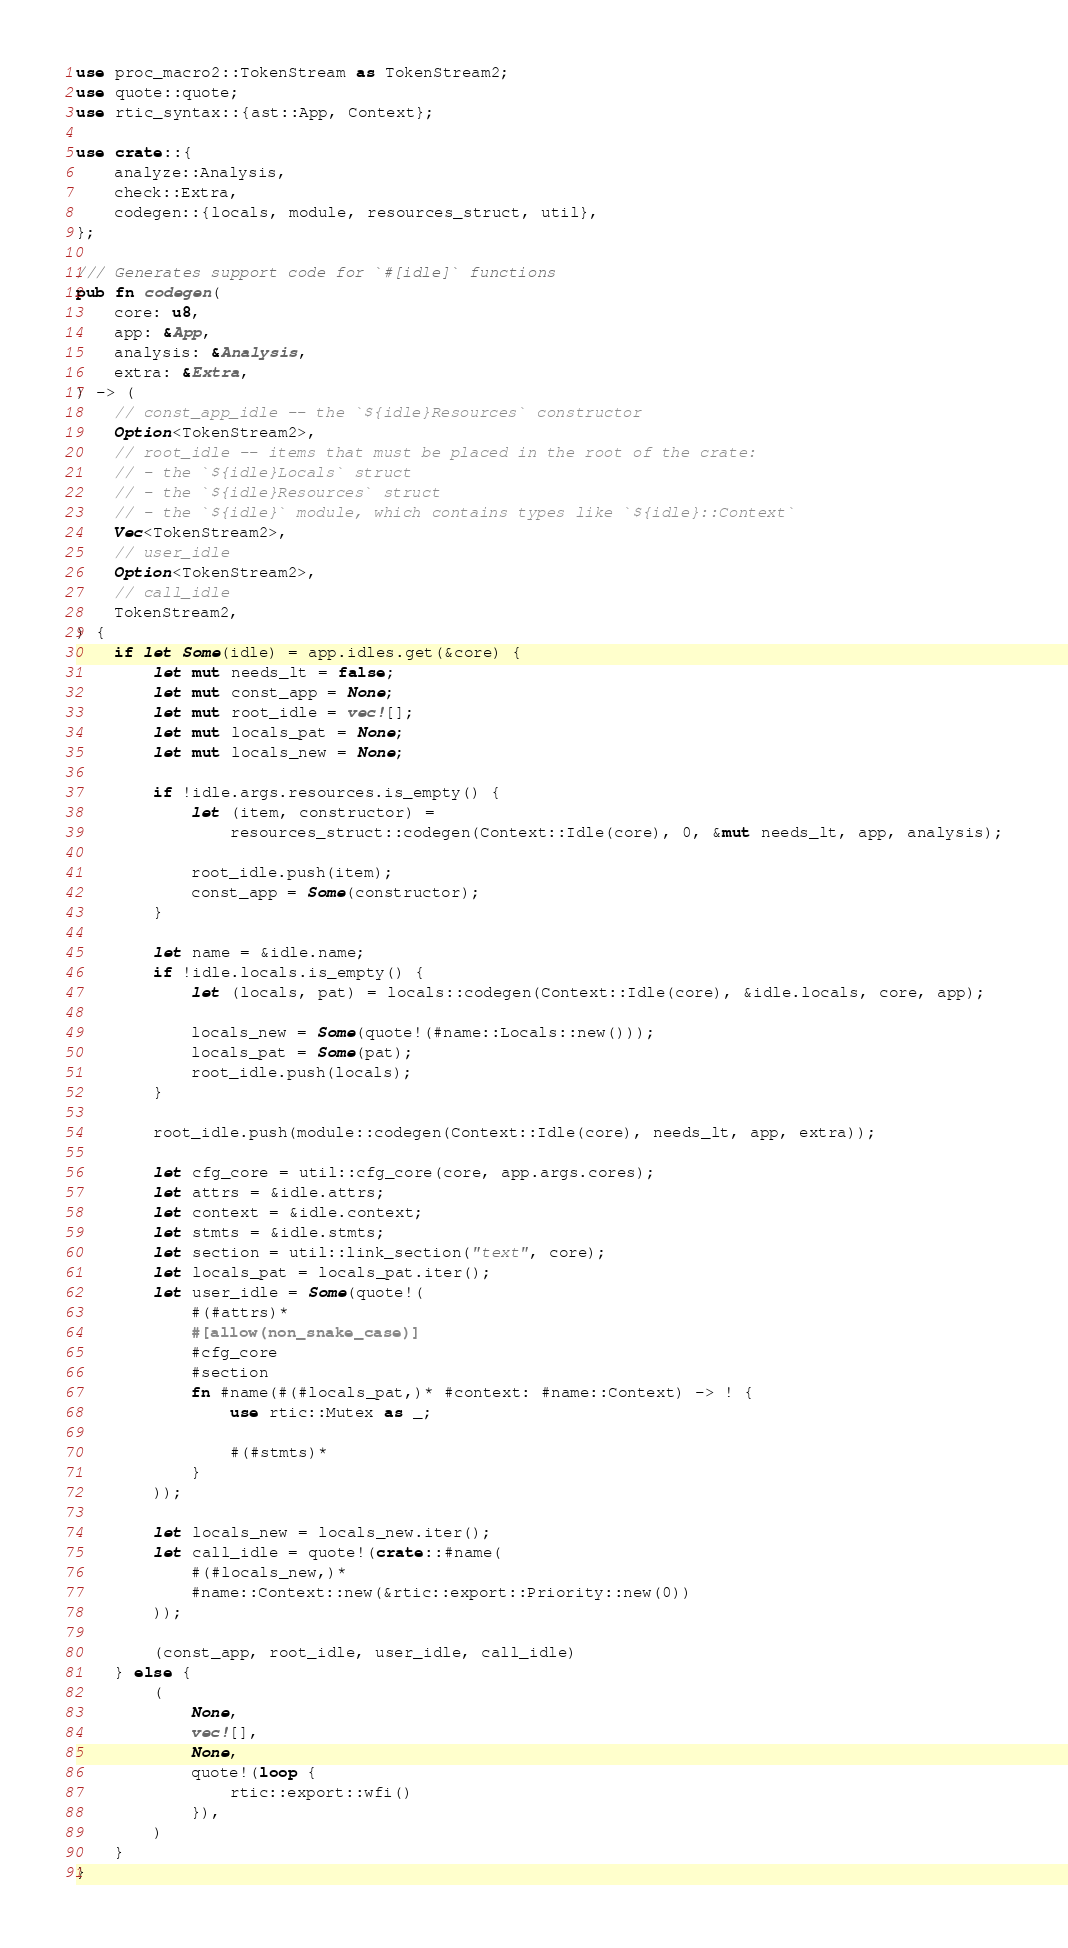Convert code to text. <code><loc_0><loc_0><loc_500><loc_500><_Rust_>use proc_macro2::TokenStream as TokenStream2;
use quote::quote;
use rtic_syntax::{ast::App, Context};

use crate::{
    analyze::Analysis,
    check::Extra,
    codegen::{locals, module, resources_struct, util},
};

/// Generates support code for `#[idle]` functions
pub fn codegen(
    core: u8,
    app: &App,
    analysis: &Analysis,
    extra: &Extra,
) -> (
    // const_app_idle -- the `${idle}Resources` constructor
    Option<TokenStream2>,
    // root_idle -- items that must be placed in the root of the crate:
    // - the `${idle}Locals` struct
    // - the `${idle}Resources` struct
    // - the `${idle}` module, which contains types like `${idle}::Context`
    Vec<TokenStream2>,
    // user_idle
    Option<TokenStream2>,
    // call_idle
    TokenStream2,
) {
    if let Some(idle) = app.idles.get(&core) {
        let mut needs_lt = false;
        let mut const_app = None;
        let mut root_idle = vec![];
        let mut locals_pat = None;
        let mut locals_new = None;

        if !idle.args.resources.is_empty() {
            let (item, constructor) =
                resources_struct::codegen(Context::Idle(core), 0, &mut needs_lt, app, analysis);

            root_idle.push(item);
            const_app = Some(constructor);
        }

        let name = &idle.name;
        if !idle.locals.is_empty() {
            let (locals, pat) = locals::codegen(Context::Idle(core), &idle.locals, core, app);

            locals_new = Some(quote!(#name::Locals::new()));
            locals_pat = Some(pat);
            root_idle.push(locals);
        }

        root_idle.push(module::codegen(Context::Idle(core), needs_lt, app, extra));

        let cfg_core = util::cfg_core(core, app.args.cores);
        let attrs = &idle.attrs;
        let context = &idle.context;
        let stmts = &idle.stmts;
        let section = util::link_section("text", core);
        let locals_pat = locals_pat.iter();
        let user_idle = Some(quote!(
            #(#attrs)*
            #[allow(non_snake_case)]
            #cfg_core
            #section
            fn #name(#(#locals_pat,)* #context: #name::Context) -> ! {
                use rtic::Mutex as _;

                #(#stmts)*
            }
        ));

        let locals_new = locals_new.iter();
        let call_idle = quote!(crate::#name(
            #(#locals_new,)*
            #name::Context::new(&rtic::export::Priority::new(0))
        ));

        (const_app, root_idle, user_idle, call_idle)
    } else {
        (
            None,
            vec![],
            None,
            quote!(loop {
                rtic::export::wfi()
            }),
        )
    }
}
</code> 